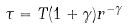<formula> <loc_0><loc_0><loc_500><loc_500>\tau = T ( 1 + \gamma ) r ^ { - \gamma }</formula> 